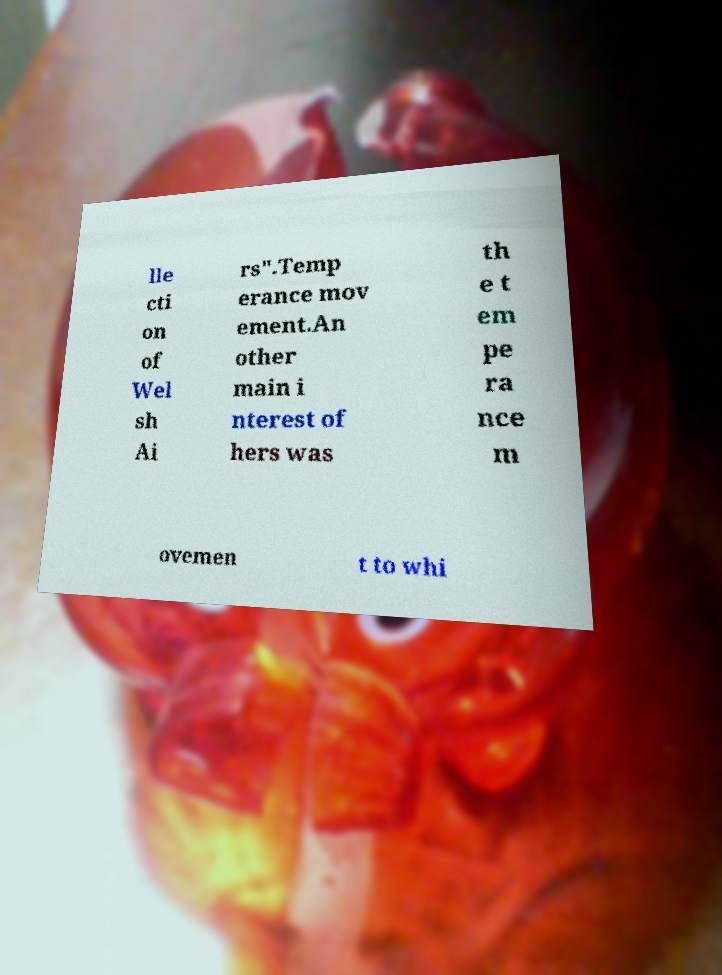Please identify and transcribe the text found in this image. lle cti on of Wel sh Ai rs".Temp erance mov ement.An other main i nterest of hers was th e t em pe ra nce m ovemen t to whi 